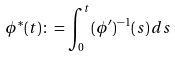Convert formula to latex. <formula><loc_0><loc_0><loc_500><loc_500>\phi ^ { \ast } ( t ) & \colon = \int _ { 0 } ^ { t } ( \phi ^ { \prime } ) ^ { - 1 } ( s ) \, d s</formula> 